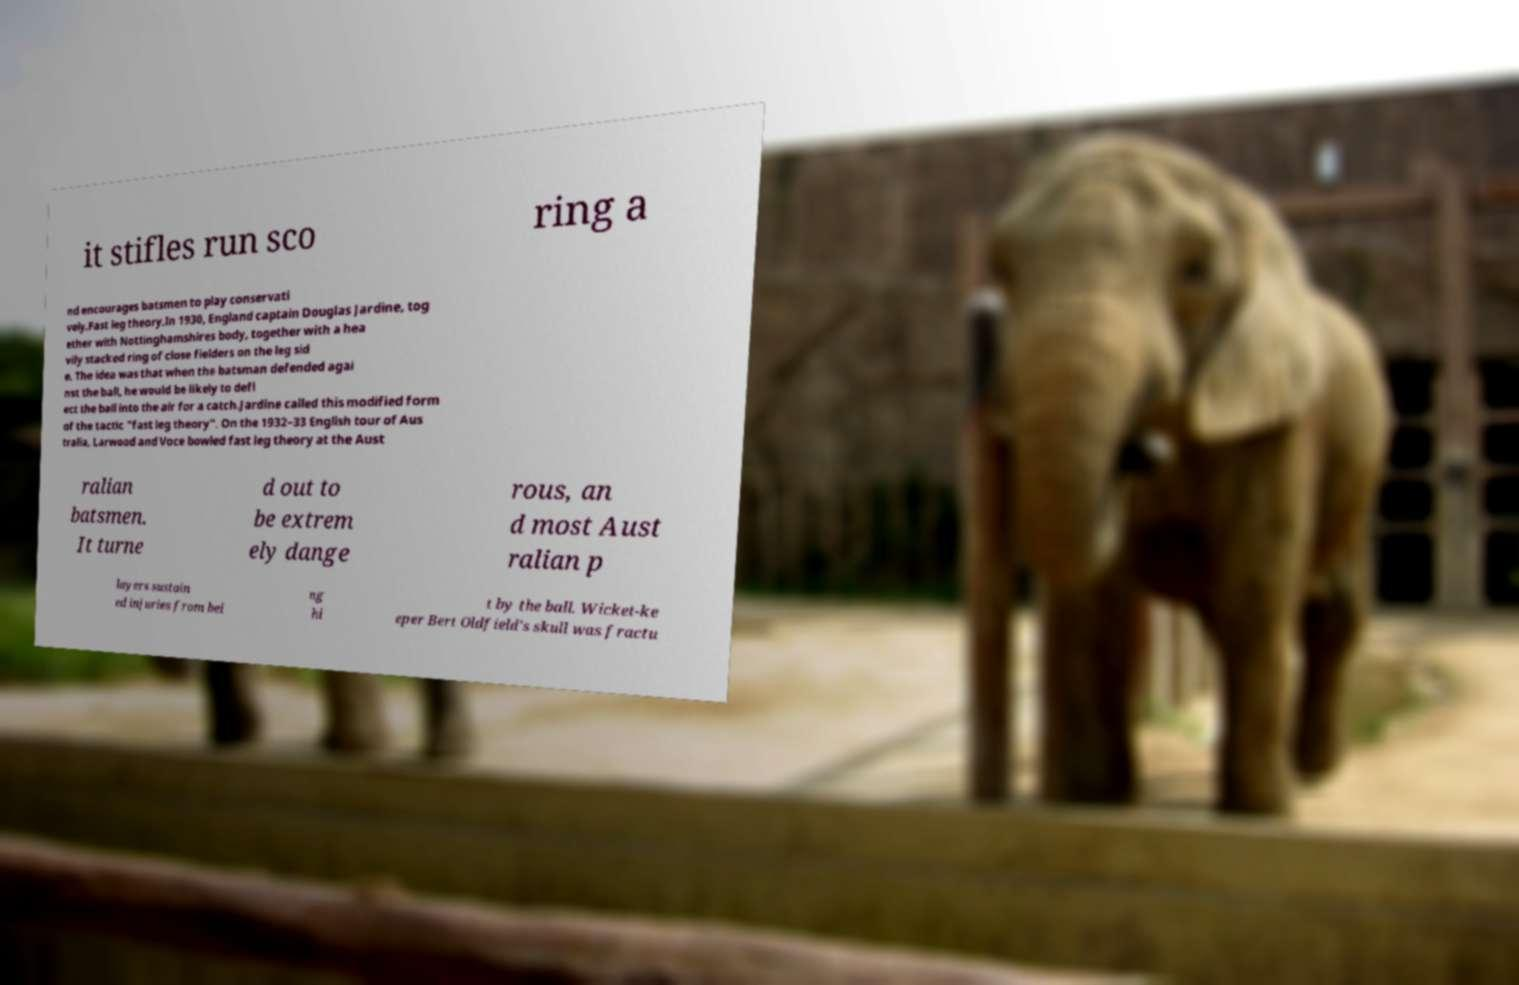Can you read and provide the text displayed in the image?This photo seems to have some interesting text. Can you extract and type it out for me? it stifles run sco ring a nd encourages batsmen to play conservati vely.Fast leg theory.In 1930, England captain Douglas Jardine, tog ether with Nottinghamshires body, together with a hea vily stacked ring of close fielders on the leg sid e. The idea was that when the batsman defended agai nst the ball, he would be likely to defl ect the ball into the air for a catch.Jardine called this modified form of the tactic "fast leg theory". On the 1932–33 English tour of Aus tralia, Larwood and Voce bowled fast leg theory at the Aust ralian batsmen. It turne d out to be extrem ely dange rous, an d most Aust ralian p layers sustain ed injuries from bei ng hi t by the ball. Wicket-ke eper Bert Oldfield's skull was fractu 